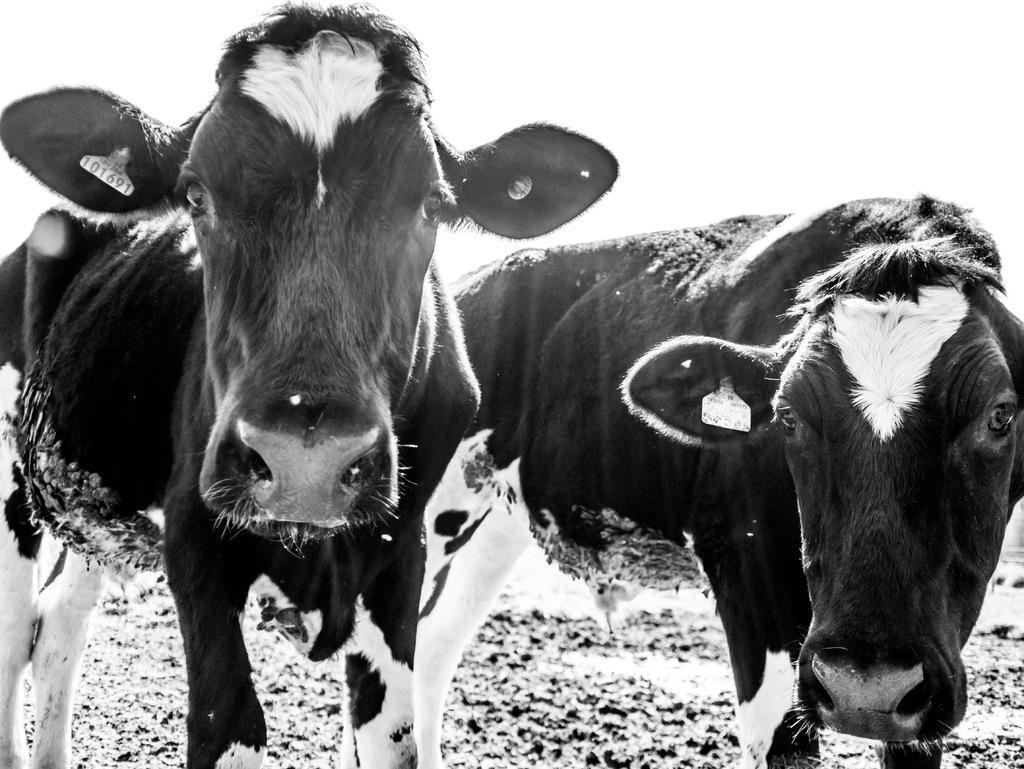Could you give a brief overview of what you see in this image? In this image I can see two cows in black and white color and this image is also in black and white color and there are tags to the ears of these cows. 